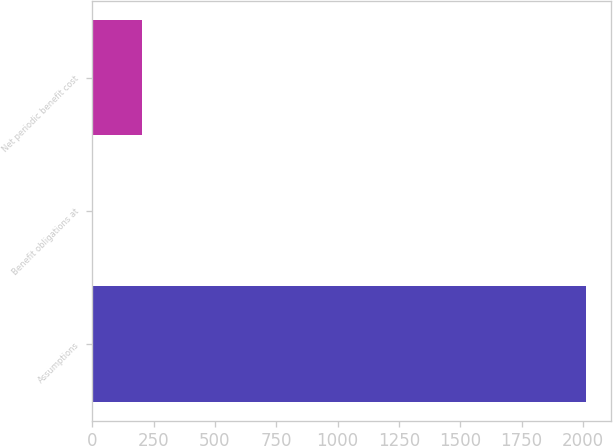Convert chart to OTSL. <chart><loc_0><loc_0><loc_500><loc_500><bar_chart><fcel>Assumptions<fcel>Benefit obligations at<fcel>Net periodic benefit cost<nl><fcel>2014<fcel>3.5<fcel>204.55<nl></chart> 